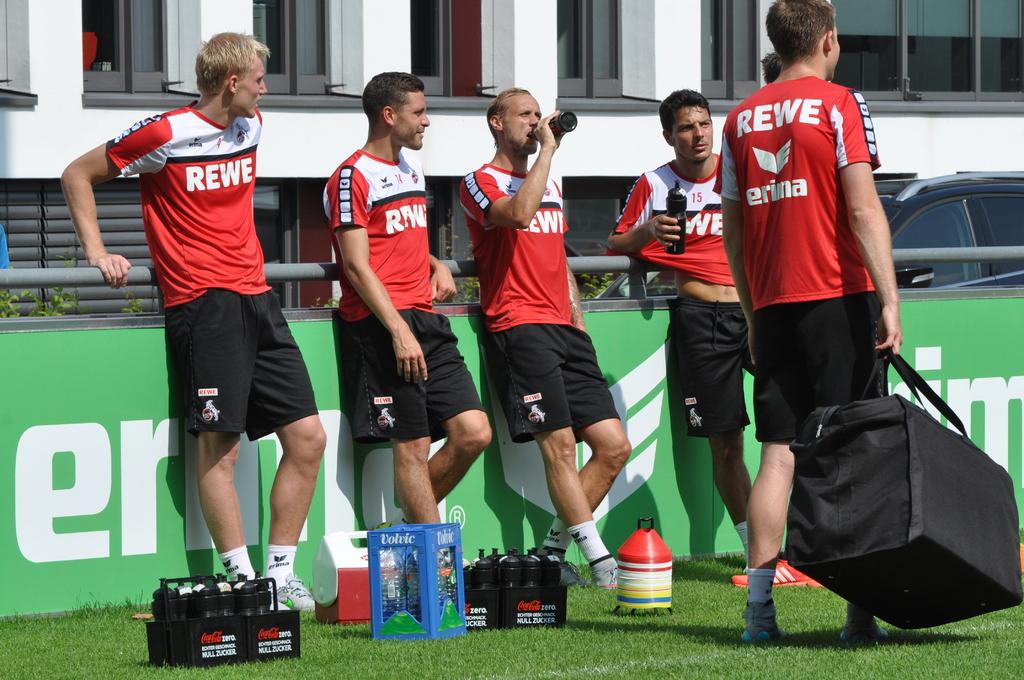Is rewe a soccer team?
Ensure brevity in your answer.  Answering does not require reading text in the image. 